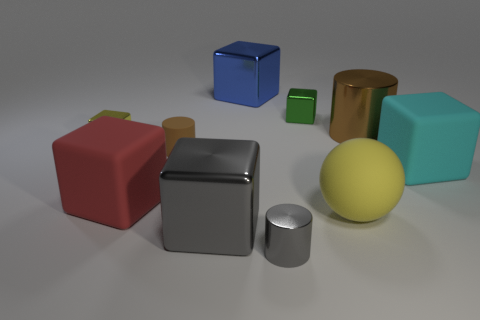The brown thing behind the yellow object on the left side of the yellow object that is to the right of the small gray metal cylinder is made of what material?
Your answer should be very brief. Metal. Are there any other things that are the same shape as the large cyan matte thing?
Make the answer very short. Yes. What color is the big object that is the same shape as the tiny gray thing?
Keep it short and to the point. Brown. Is the color of the metallic cylinder in front of the big cyan cube the same as the large block on the right side of the tiny gray metallic object?
Give a very brief answer. No. Is the number of gray shiny objects to the right of the big cyan matte cube greater than the number of red rubber cubes?
Keep it short and to the point. No. What number of other objects are there of the same size as the cyan rubber block?
Provide a short and direct response. 5. What number of metallic things are both behind the tiny green object and in front of the large blue metallic object?
Make the answer very short. 0. Do the small cube to the left of the gray metallic block and the large yellow object have the same material?
Your answer should be compact. No. There is a large metal object that is right of the large block behind the yellow thing that is left of the small brown object; what is its shape?
Give a very brief answer. Cylinder. Are there the same number of rubber objects behind the green object and brown cylinders that are behind the blue metal object?
Keep it short and to the point. Yes. 